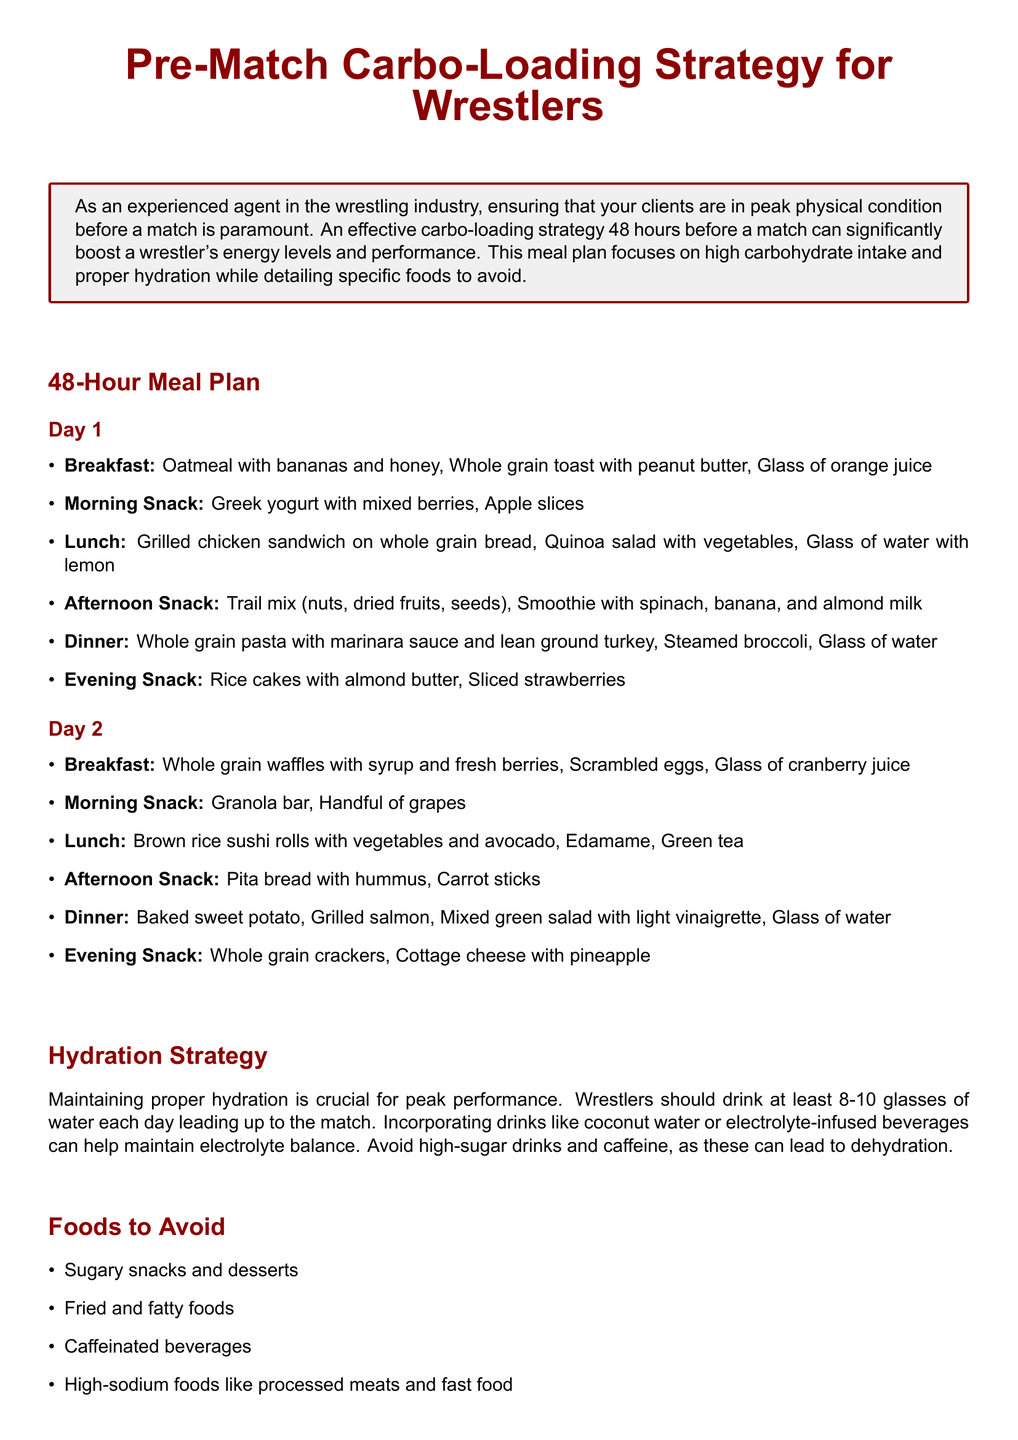What is the title of the document? The title appears at the beginning of the document, stating the focus on the meal plan for wrestlers.
Answer: Pre-Match Carbo-Loading Strategy for Wrestlers How many glasses of water should wrestlers drink each day? The hydration strategy specifies the daily water intake recommended before a match.
Answer: 8-10 glasses What food is included in the Day 1 breakfast? The Day 1 breakfast lists specific foods that wrestlers should eat, including oatmeal and bananas.
Answer: Oatmeal with bananas and honey Which food group is suggested for the Day 2 evening snack? The Day 2 evening snack focuses on specific food items that fit within the meal plan guidelines.
Answer: Whole grain crackers What type of foods should be avoided? The document outlines specific categories of foods that should not be consumed before the match.
Answer: Sugary snacks and desserts What is the purpose of the meal plan? The introduction highlights the goal of the plan in relation to wrestling performance.
Answer: Boost energy levels What is a recommended source of hydration other than water? The hydration strategy lists alternatives to plain water for maintaining electrolyte balance.
Answer: Coconut water What is included in the Day 1 afternoon snack? The Day 1 afternoon snack is specified to provide both energy and nutrients before a match.
Answer: Trail mix (nuts, dried fruits, seeds) 